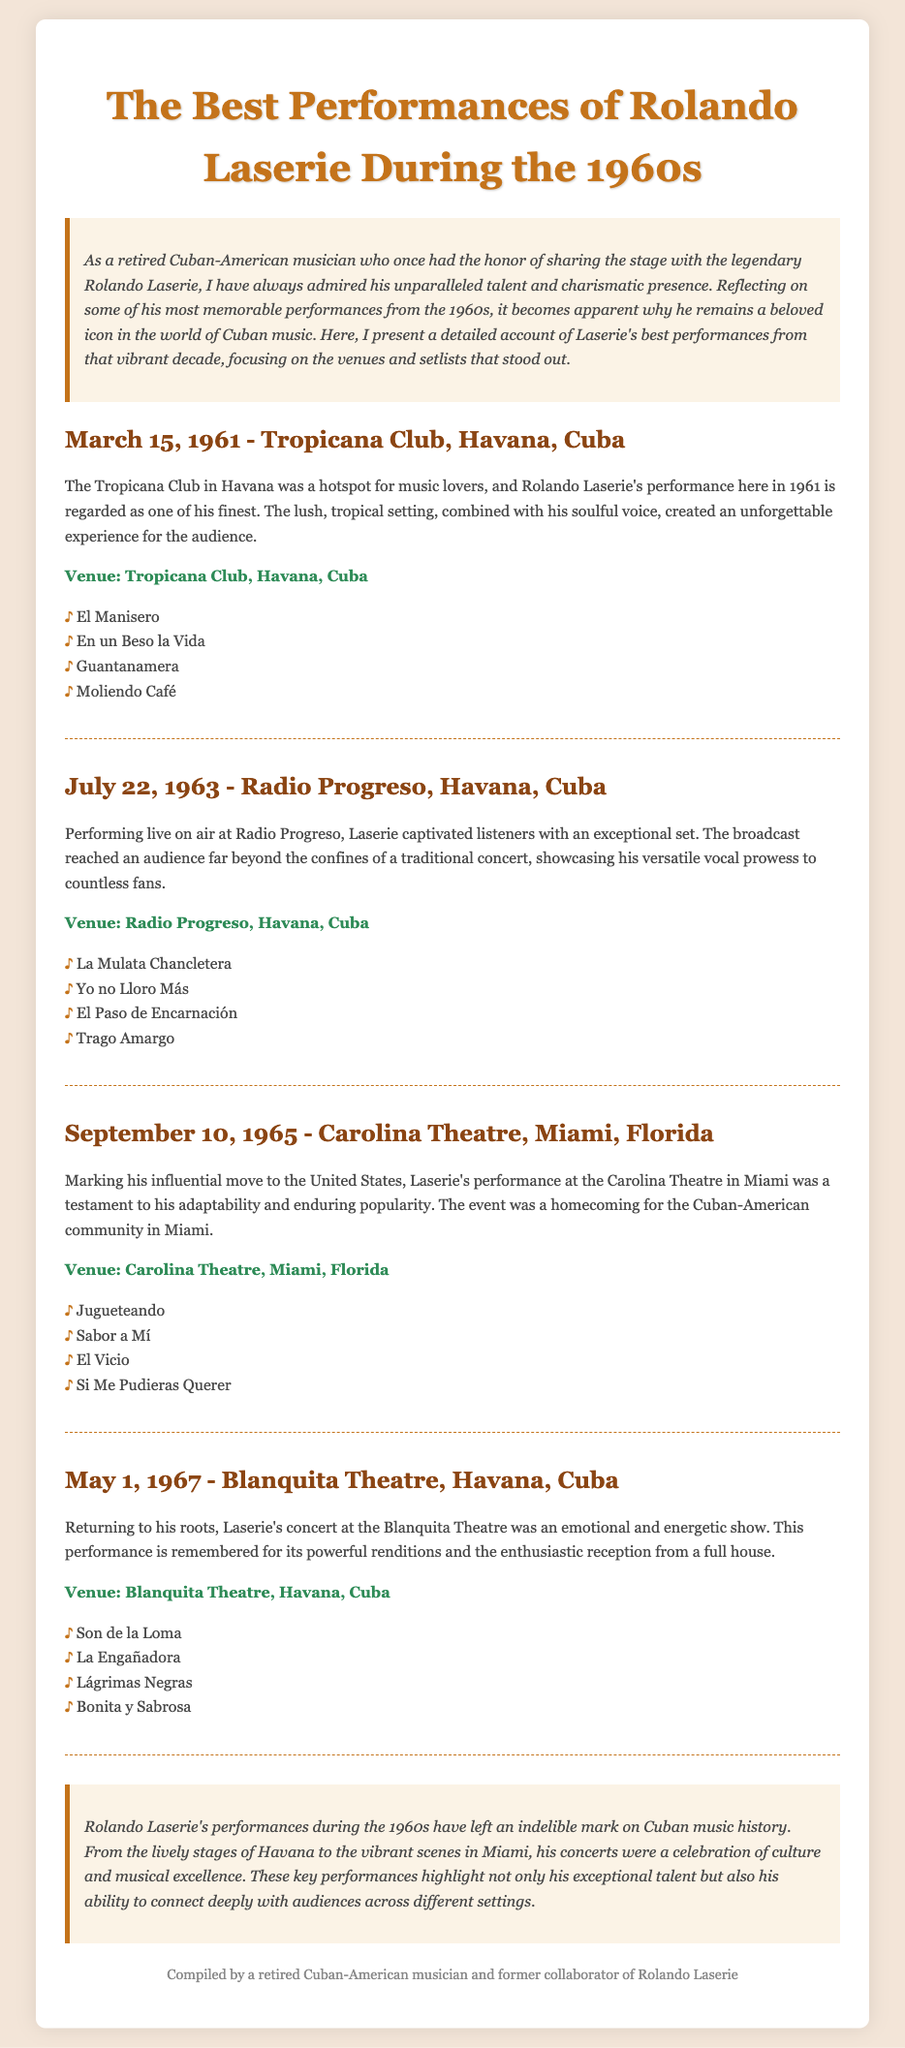What was the date of Rolando Laserie's performance at the Tropicana Club? The performance at the Tropicana Club occurred on March 15, 1961.
Answer: March 15, 1961 Where did Rolando Laserie perform on July 22, 1963? He performed at Radio Progreso in Havana, Cuba.
Answer: Radio Progreso, Havana, Cuba What song was performed at the Blanquita Theatre on May 1, 1967? One of the songs performed was "Son de la Loma."
Answer: Son de la Loma How many venues are mentioned in the document? The document lists four distinct venues where performances took place.
Answer: Four Which performance marked Rolando Laserie's influential move to the United States? The performance at the Carolina Theatre in Miami, Florida represents his move.
Answer: Carolina Theatre, Miami, Florida What is the main theme discussed in the conclusion? The conclusion highlights Laserie’s impact on Cuban music history through his performances.
Answer: Impact on Cuban music history Which song appears in both the setlist for Radio Progreso and the setlist for Tropicana Club? "Moliendo Café" does not appear in both setlists; this requires a careful comparison. The correct answer is that no song is repeated.
Answer: No song repeated What is the color of the heading for Rolando Laserie's performances? The heading color for each performance is a shade of brown.
Answer: Brown 